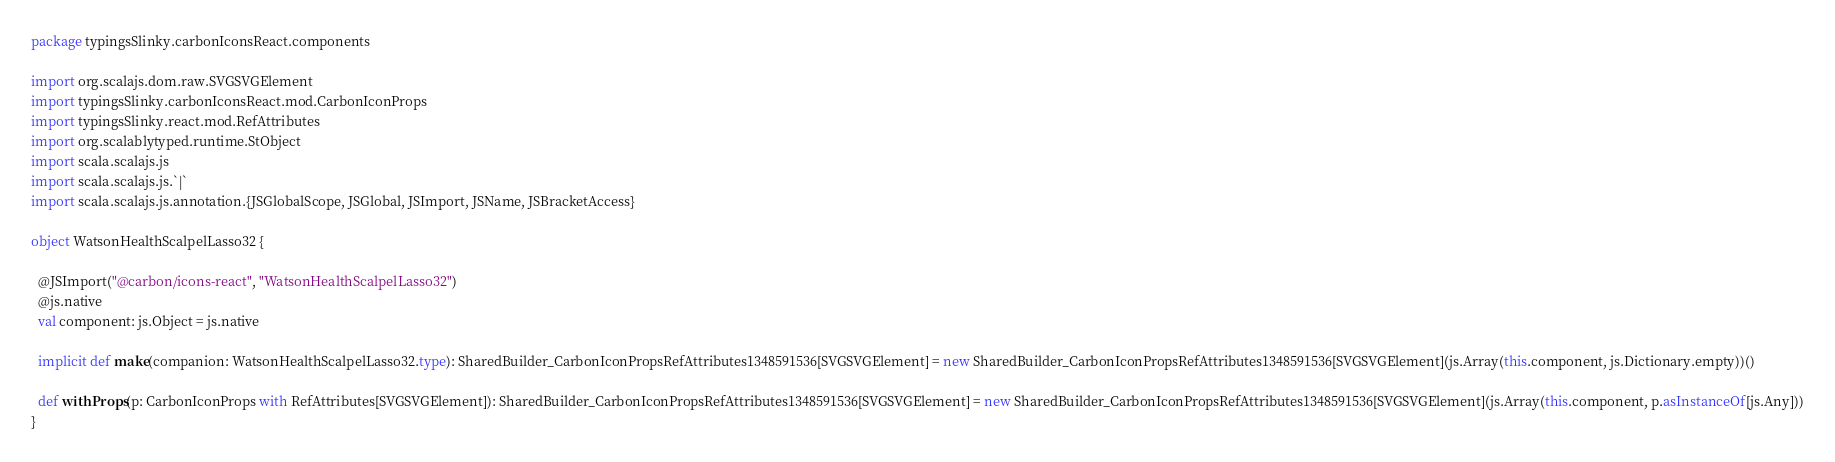<code> <loc_0><loc_0><loc_500><loc_500><_Scala_>package typingsSlinky.carbonIconsReact.components

import org.scalajs.dom.raw.SVGSVGElement
import typingsSlinky.carbonIconsReact.mod.CarbonIconProps
import typingsSlinky.react.mod.RefAttributes
import org.scalablytyped.runtime.StObject
import scala.scalajs.js
import scala.scalajs.js.`|`
import scala.scalajs.js.annotation.{JSGlobalScope, JSGlobal, JSImport, JSName, JSBracketAccess}

object WatsonHealthScalpelLasso32 {
  
  @JSImport("@carbon/icons-react", "WatsonHealthScalpelLasso32")
  @js.native
  val component: js.Object = js.native
  
  implicit def make(companion: WatsonHealthScalpelLasso32.type): SharedBuilder_CarbonIconPropsRefAttributes1348591536[SVGSVGElement] = new SharedBuilder_CarbonIconPropsRefAttributes1348591536[SVGSVGElement](js.Array(this.component, js.Dictionary.empty))()
  
  def withProps(p: CarbonIconProps with RefAttributes[SVGSVGElement]): SharedBuilder_CarbonIconPropsRefAttributes1348591536[SVGSVGElement] = new SharedBuilder_CarbonIconPropsRefAttributes1348591536[SVGSVGElement](js.Array(this.component, p.asInstanceOf[js.Any]))
}
</code> 